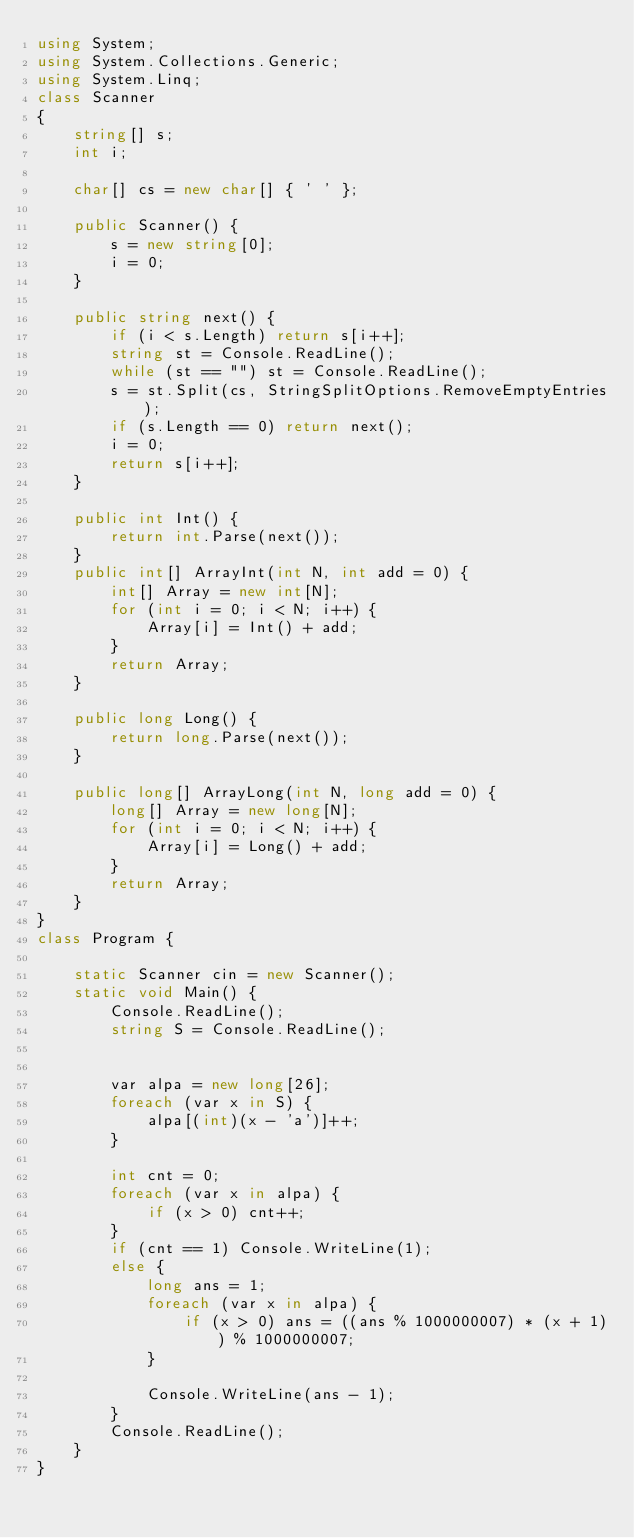Convert code to text. <code><loc_0><loc_0><loc_500><loc_500><_C#_>using System;
using System.Collections.Generic;
using System.Linq;
class Scanner
{
    string[] s;
    int i;

    char[] cs = new char[] { ' ' };

    public Scanner() {
        s = new string[0];
        i = 0;
    }

    public string next() {
        if (i < s.Length) return s[i++];
        string st = Console.ReadLine();
        while (st == "") st = Console.ReadLine();
        s = st.Split(cs, StringSplitOptions.RemoveEmptyEntries);
        if (s.Length == 0) return next();
        i = 0;
        return s[i++];
    }

    public int Int() {
        return int.Parse(next());
    }
    public int[] ArrayInt(int N, int add = 0) {
        int[] Array = new int[N];
        for (int i = 0; i < N; i++) {
            Array[i] = Int() + add;
        }
        return Array;
    }

    public long Long() {
        return long.Parse(next());
    }

    public long[] ArrayLong(int N, long add = 0) {
        long[] Array = new long[N];
        for (int i = 0; i < N; i++) {
            Array[i] = Long() + add;
        }
        return Array;
    }
}
class Program {
   
    static Scanner cin = new Scanner();
    static void Main() {
        Console.ReadLine();
        string S = Console.ReadLine();

        
        var alpa = new long[26];
        foreach (var x in S) {
            alpa[(int)(x - 'a')]++;
        }

        int cnt = 0;
        foreach (var x in alpa) {
            if (x > 0) cnt++;
        }
        if (cnt == 1) Console.WriteLine(1);
        else {
            long ans = 1;
            foreach (var x in alpa) {
                if (x > 0) ans = ((ans % 1000000007) * (x + 1)) % 1000000007;
            }

            Console.WriteLine(ans - 1);
        }
        Console.ReadLine();
    }
}</code> 